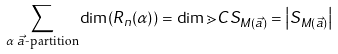Convert formula to latex. <formula><loc_0><loc_0><loc_500><loc_500>\sum _ { \alpha \text { $\vec{a}$-partition} } \dim ( R _ { n } ( \alpha ) ) = \dim \mathbb { m } { C } S _ { M ( \vec { a } ) } = \left | S _ { M ( \vec { a } ) } \right |</formula> 